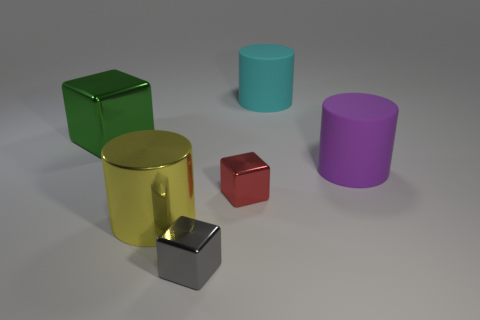Is the number of purple rubber things greater than the number of big cylinders?
Provide a short and direct response. No. There is a large rubber cylinder on the right side of the large matte cylinder behind the large purple matte cylinder; is there a cylinder that is in front of it?
Provide a short and direct response. Yes. How many other objects are there of the same size as the purple thing?
Your response must be concise. 3. There is a large cyan thing; are there any red shiny things to the left of it?
Offer a terse response. Yes. There is a big cylinder that is in front of the large rubber object in front of the rubber thing behind the large green object; what is its color?
Provide a short and direct response. Yellow. Are there any rubber objects of the same shape as the large green metal thing?
Provide a succinct answer. No. What color is the other shiny block that is the same size as the gray cube?
Your answer should be very brief. Red. There is a large cyan cylinder that is right of the shiny cylinder; what material is it?
Keep it short and to the point. Rubber. There is a tiny metal thing behind the gray shiny cube; does it have the same shape as the large metal thing on the right side of the large green thing?
Offer a very short reply. No. Is the number of cyan matte cylinders to the right of the big purple cylinder the same as the number of brown rubber blocks?
Your answer should be very brief. Yes. 